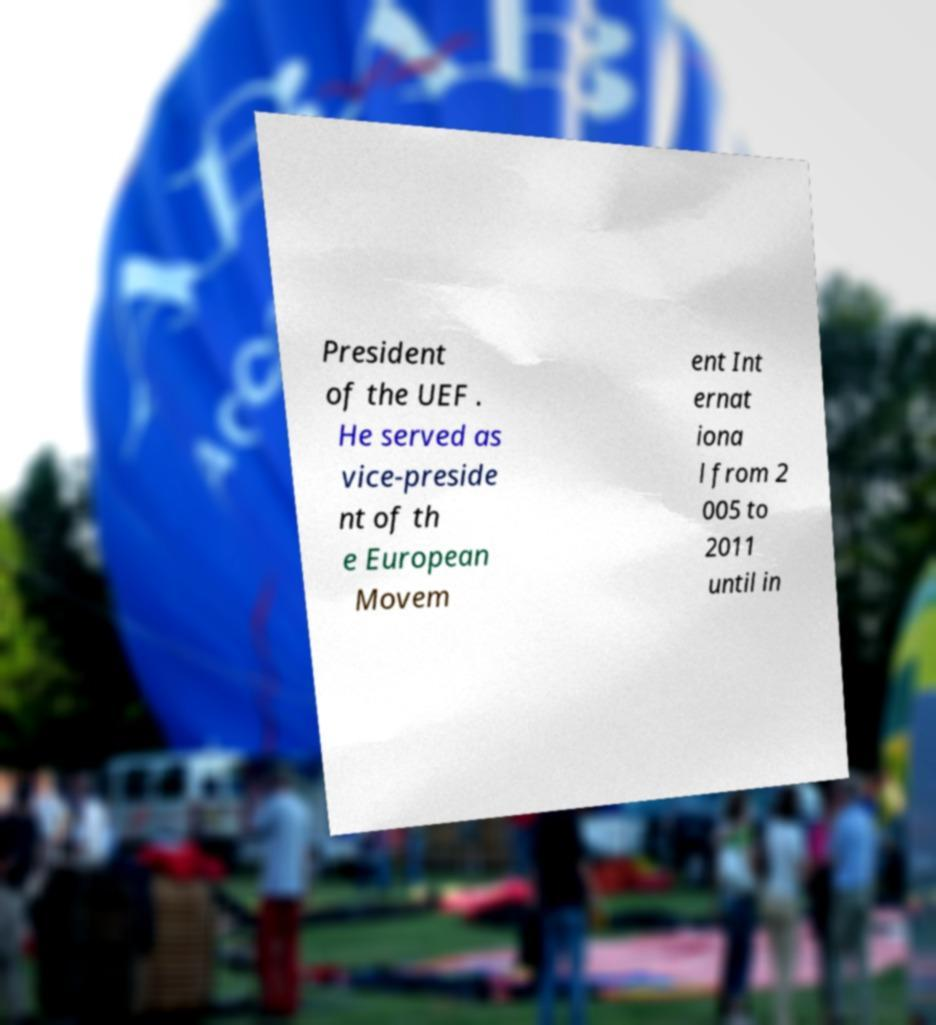What messages or text are displayed in this image? I need them in a readable, typed format. President of the UEF . He served as vice-preside nt of th e European Movem ent Int ernat iona l from 2 005 to 2011 until in 